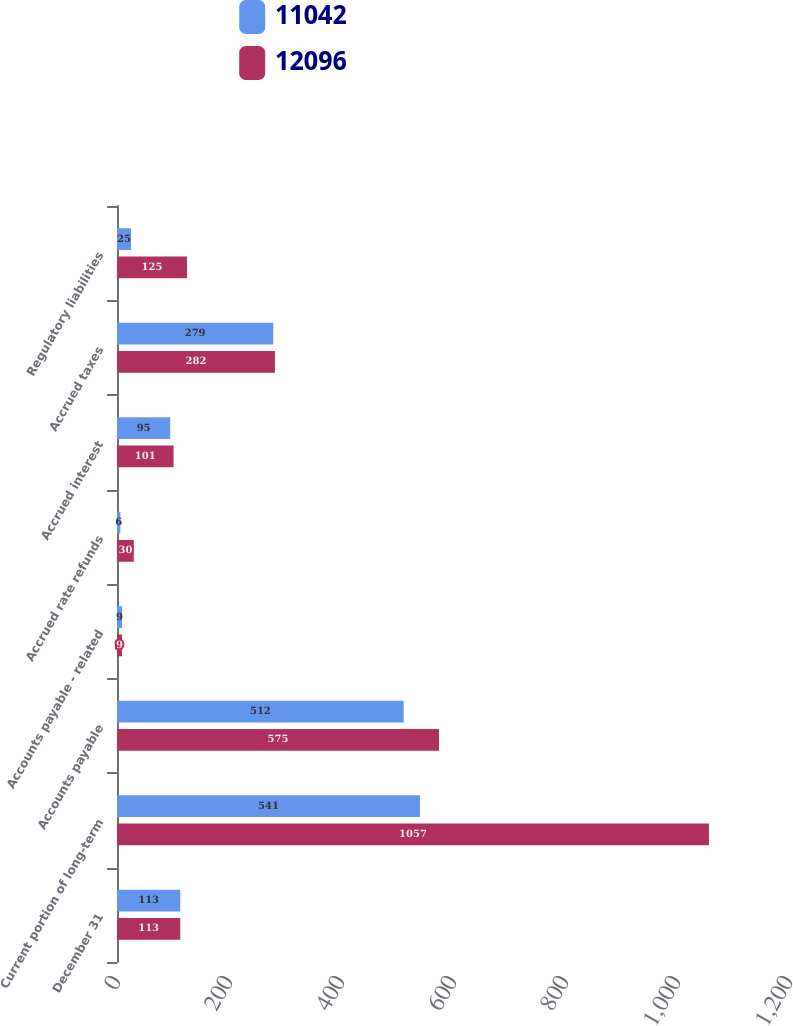Convert chart to OTSL. <chart><loc_0><loc_0><loc_500><loc_500><stacked_bar_chart><ecel><fcel>December 31<fcel>Current portion of long-term<fcel>Accounts payable<fcel>Accounts payable - related<fcel>Accrued rate refunds<fcel>Accrued interest<fcel>Accrued taxes<fcel>Regulatory liabilities<nl><fcel>11042<fcel>113<fcel>541<fcel>512<fcel>9<fcel>6<fcel>95<fcel>279<fcel>25<nl><fcel>12096<fcel>113<fcel>1057<fcel>575<fcel>9<fcel>30<fcel>101<fcel>282<fcel>125<nl></chart> 